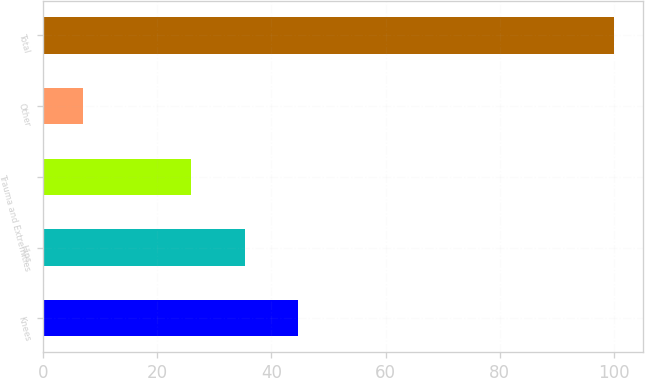Convert chart to OTSL. <chart><loc_0><loc_0><loc_500><loc_500><bar_chart><fcel>Knees<fcel>Hips<fcel>Trauma and Extremities<fcel>Other<fcel>Total<nl><fcel>44.6<fcel>35.3<fcel>26<fcel>7<fcel>100<nl></chart> 